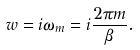Convert formula to latex. <formula><loc_0><loc_0><loc_500><loc_500>w = i \omega _ { m } = i \frac { 2 \pi m } { \beta } .</formula> 